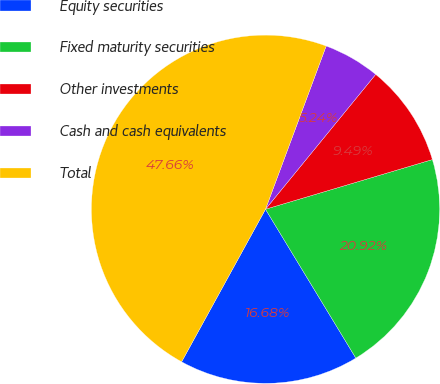Convert chart. <chart><loc_0><loc_0><loc_500><loc_500><pie_chart><fcel>Equity securities<fcel>Fixed maturity securities<fcel>Other investments<fcel>Cash and cash equivalents<fcel>Total<nl><fcel>16.68%<fcel>20.92%<fcel>9.49%<fcel>5.24%<fcel>47.66%<nl></chart> 